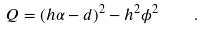<formula> <loc_0><loc_0><loc_500><loc_500>Q = ( h \alpha - d ) ^ { 2 } - h ^ { 2 } \phi ^ { 2 } \quad .</formula> 